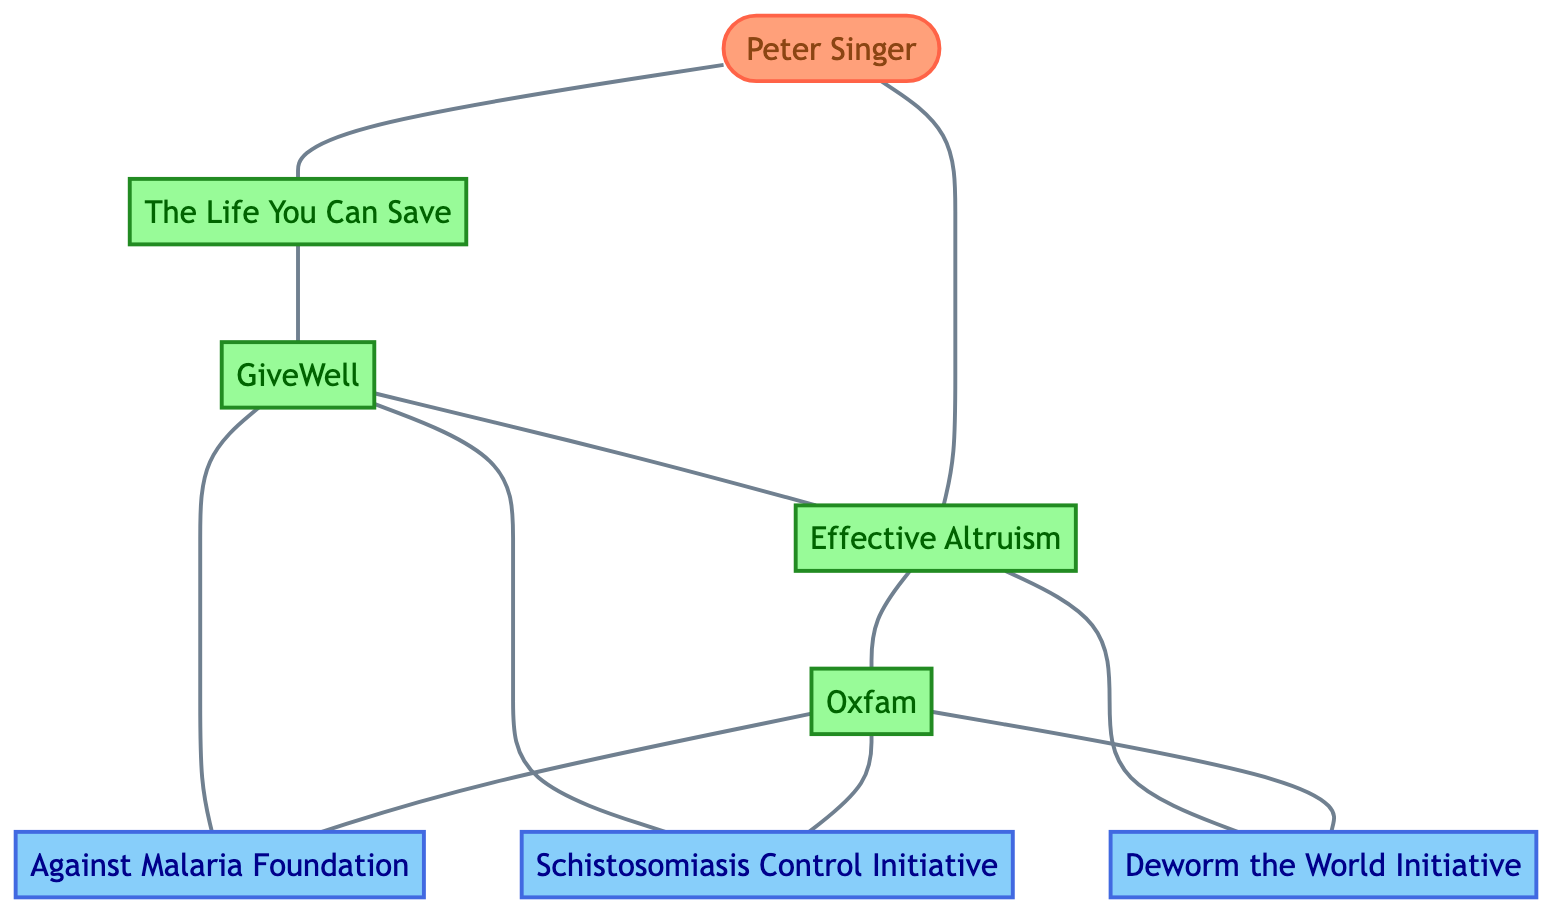What is the total number of nodes in the diagram? The diagram lists a total of eight distinct entities: Peter Singer, The Life You Can Save, GiveWell, Effective Altruism, Oxfam, Against Malaria Foundation, Schistosomiasis Control Initiative, and Deworm the World Initiative. Thus, we can count them to find that there are eight nodes.
Answer: 8 How many edges connect to Oxfam? To determine how many edges connect to Oxfam, we can examine the edges present in the diagram. Oxfam has three edges connecting it to Effective Altruism, Against Malaria Foundation, Schistosomiasis Control Initiative, and Deworm the World Initiative. Counting these edges gives us a total of four edges.
Answer: 4 Which node is a direct neighbor of GiveWell in the graph? A direct neighbor of GiveWell can be identified by looking at the edges connected to GiveWell. From the diagram edges, it is clear that GiveWell directly connects to The Life You Can Save, Effective Altruism, Against Malaria Foundation, and Schistosomiasis Control Initiative. Thus, there are multiple direct neighbors, but focusing on one, we can say The Life You Can Save is a direct neighbor.
Answer: The Life You Can Save What is the relationship between Peter Singer and Effective Altruism? The relationship between Peter Singer and Effective Altruism is indicated by the edge directly connecting these two nodes in the diagram. Since there is a direct connection (an edge) between them, we can conclude that Peter Singer supports or is associated with Effective Altruism.
Answer: Direct connection How many organizations are represented in the diagram, excluding initiatives and philosophers? Analyzing the nodes, the organizations include The Life You Can Save, GiveWell, Effective Altruism, and Oxfam. There are four organizations noted in the diagram, with initiatives being Against Malaria Foundation, Schistosomiasis Control Initiative, and Deworm the World Initiative. Thus, we have four organizations in total.
Answer: 4 Which two initiatives are directly connected to GiveWell? To find out which initiatives are directly connected to GiveWell, we check the edges that are connected to the GiveWell node. From the graph, we see that GiveWell is connected to Against Malaria Foundation and Schistosomiasis Control Initiative.
Answer: Against Malaria Foundation, Schistosomiasis Control Initiative Identify one node that has the most connections in the diagram. By examining the edges emanating from each node, we can see that Oxfam has four connections (related to GiveWell, Effective Altruism, Against Malaria Foundation, Schistosomiasis Control Initiative, and Deworm the World Initiative). Thus, Oxfam holds the highest number of connections in the diagram.
Answer: Oxfam Which node serves as a source for the most edges in the diagram? After reviewing the edges, we see that GiveWell has four edges connected to it (to Effective Altruism, Oxfam, Against Malaria Foundation, and Schistosomiasis Control Initiative). Therefore, it serves as a source for the most edges in the diagram.
Answer: GiveWell 